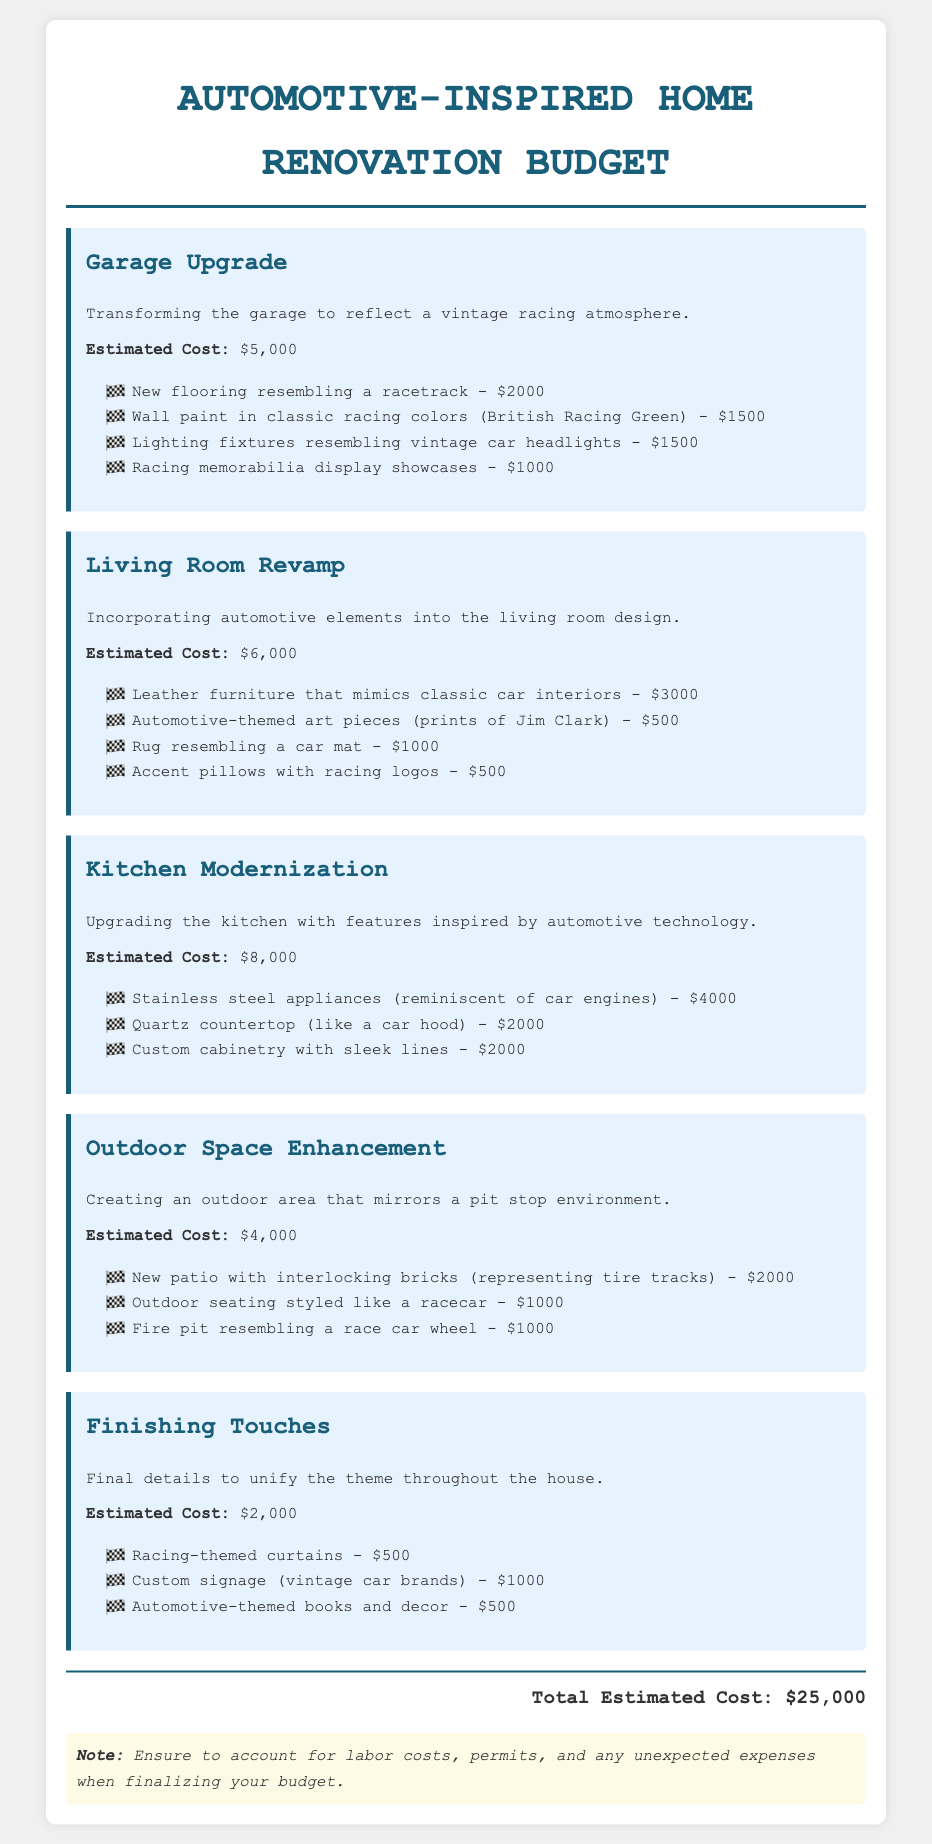What is the estimated cost for the garage upgrade? The estimated cost for the garage upgrade is explicitly stated in the document.
Answer: $5,000 What is one of the materials used for flooring in the garage? The document lists specific items under the garage upgrade, including the new flooring.
Answer: Racetrack How much is allocated for the living room revamp? The estimated cost for the living room revamp is provided as a total amount in the section.
Answer: $6,000 What kind of furniture is included in the living room budget? The details in the living room section specify a type of furniture inspired by classic cars.
Answer: Leather How many items are listed under the kitchen modernization section? The kitchen section lists specific upgrades, and counting them reveals the number of items.
Answer: 3 If I want to enhance my outdoor space, how much should I budget? The total estimated cost for enhancing the outdoor space is specified in that section.
Answer: $4,000 What is the theme of the curtains mentioned in the finishing touches? The document refers to a specific theme for the curtains under finishing touches.
Answer: Racing How much is spent on racing-themed curtains? The cost for racing-themed curtains is given as part of the finishing touches expenses.
Answer: $500 What is the total estimated cost for the entire renovation project? The overall total is explicitly summed in the document as a final amount.
Answer: $25,000 What should be considered in addition to the budget estimates? The document notes additional considerations to keep in mind when planning the budget.
Answer: Labor costs 